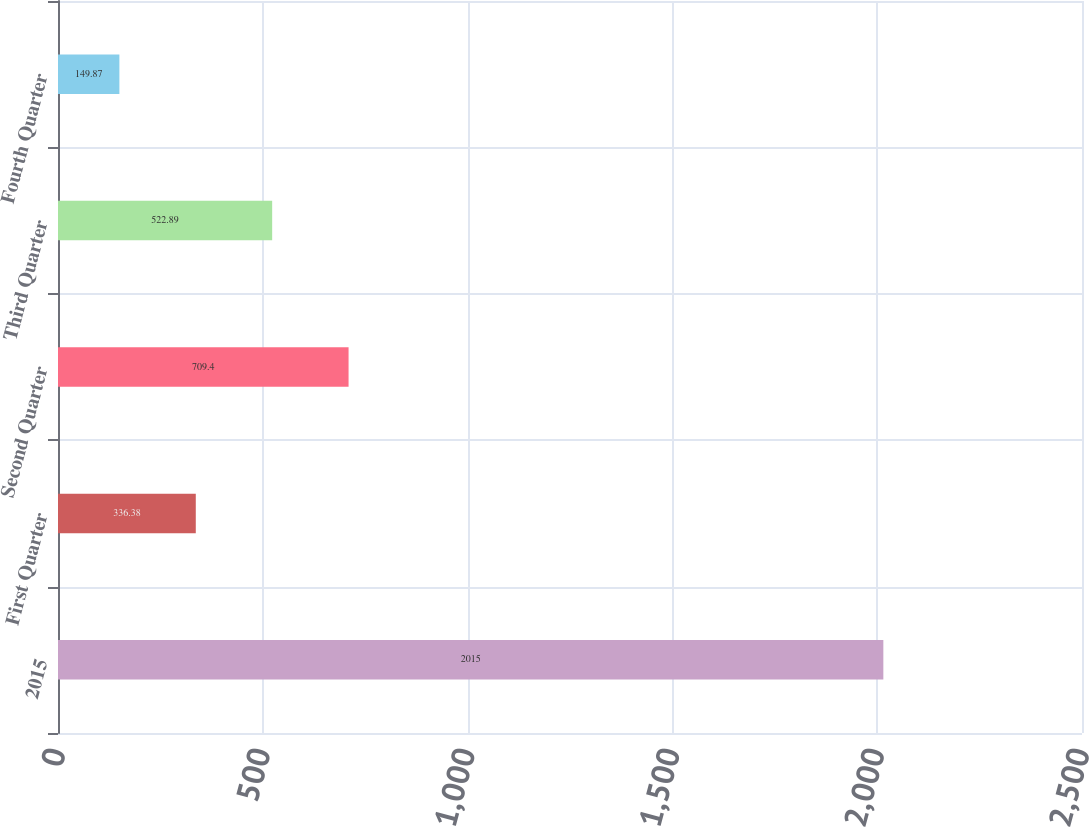<chart> <loc_0><loc_0><loc_500><loc_500><bar_chart><fcel>2015<fcel>First Quarter<fcel>Second Quarter<fcel>Third Quarter<fcel>Fourth Quarter<nl><fcel>2015<fcel>336.38<fcel>709.4<fcel>522.89<fcel>149.87<nl></chart> 